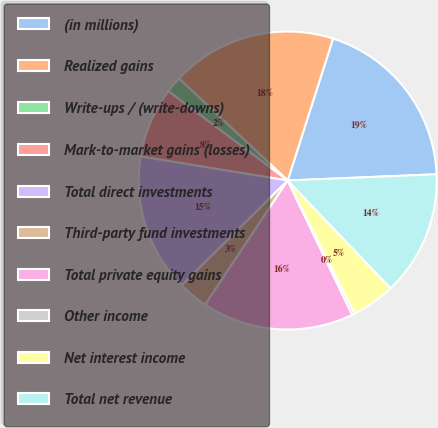Convert chart to OTSL. <chart><loc_0><loc_0><loc_500><loc_500><pie_chart><fcel>(in millions)<fcel>Realized gains<fcel>Write-ups / (write-downs)<fcel>Mark-to-market gains (losses)<fcel>Total direct investments<fcel>Third-party fund investments<fcel>Total private equity gains<fcel>Other income<fcel>Net interest income<fcel>Total net revenue<nl><fcel>19.41%<fcel>17.94%<fcel>1.77%<fcel>7.65%<fcel>15.0%<fcel>3.24%<fcel>16.47%<fcel>0.3%<fcel>4.71%<fcel>13.53%<nl></chart> 